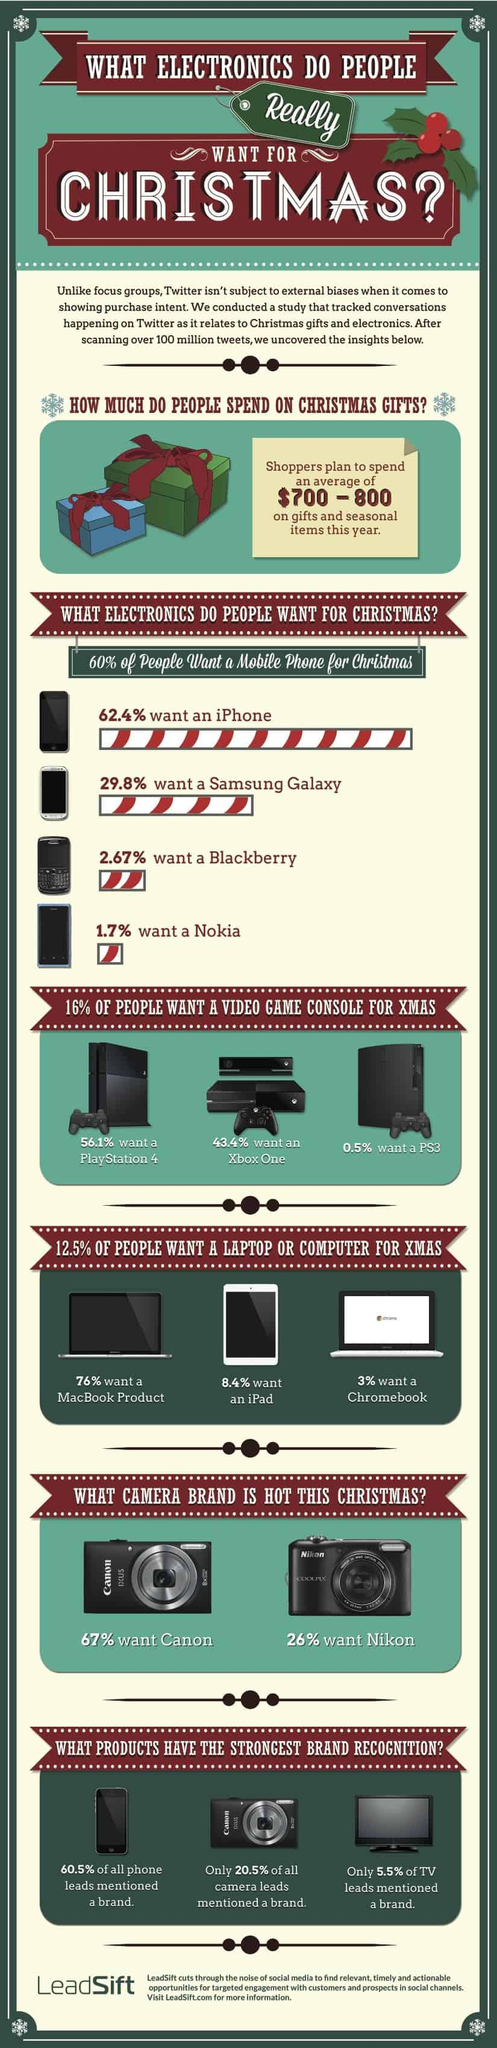Outline some significant characteristics in this image. It is clear that the iPhone is the most desired smartphone among people for the holiday season. A large majority of people, 76%, want a MacBook product for Christmas. It is clear that Nokia is the least desired phone among people for Christmas. According to a recent survey, 43.4% of people plan to purchase a Xbox One as a gift for Christmas. Ninety-seven percent of people do not need a Chromebook for Christmas. 